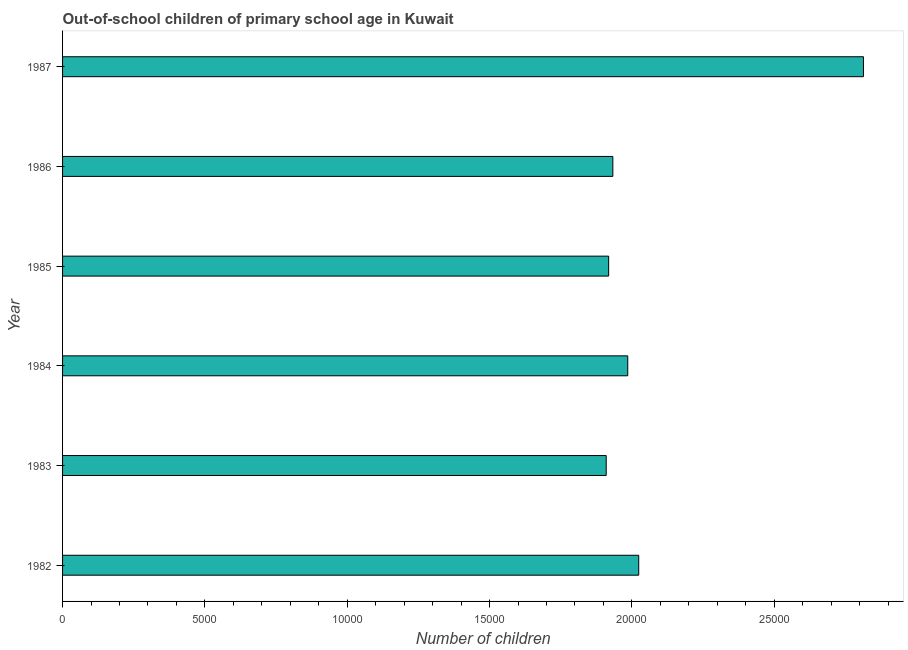Does the graph contain any zero values?
Give a very brief answer. No. What is the title of the graph?
Offer a terse response. Out-of-school children of primary school age in Kuwait. What is the label or title of the X-axis?
Your answer should be very brief. Number of children. What is the number of out-of-school children in 1982?
Make the answer very short. 2.02e+04. Across all years, what is the maximum number of out-of-school children?
Keep it short and to the point. 2.81e+04. Across all years, what is the minimum number of out-of-school children?
Ensure brevity in your answer.  1.91e+04. In which year was the number of out-of-school children minimum?
Your response must be concise. 1983. What is the sum of the number of out-of-school children?
Provide a short and direct response. 1.26e+05. What is the difference between the number of out-of-school children in 1982 and 1983?
Give a very brief answer. 1142. What is the average number of out-of-school children per year?
Make the answer very short. 2.10e+04. What is the median number of out-of-school children?
Your answer should be very brief. 1.96e+04. In how many years, is the number of out-of-school children greater than 8000 ?
Provide a succinct answer. 6. Do a majority of the years between 1984 and 1982 (inclusive) have number of out-of-school children greater than 15000 ?
Provide a succinct answer. Yes. What is the ratio of the number of out-of-school children in 1985 to that in 1986?
Provide a short and direct response. 0.99. What is the difference between the highest and the second highest number of out-of-school children?
Provide a succinct answer. 7895. Is the sum of the number of out-of-school children in 1984 and 1987 greater than the maximum number of out-of-school children across all years?
Ensure brevity in your answer.  Yes. What is the difference between the highest and the lowest number of out-of-school children?
Offer a terse response. 9037. Are all the bars in the graph horizontal?
Ensure brevity in your answer.  Yes. What is the difference between two consecutive major ticks on the X-axis?
Your answer should be compact. 5000. What is the Number of children of 1982?
Ensure brevity in your answer.  2.02e+04. What is the Number of children in 1983?
Your answer should be compact. 1.91e+04. What is the Number of children in 1984?
Your answer should be compact. 1.99e+04. What is the Number of children in 1985?
Keep it short and to the point. 1.92e+04. What is the Number of children in 1986?
Give a very brief answer. 1.93e+04. What is the Number of children of 1987?
Your response must be concise. 2.81e+04. What is the difference between the Number of children in 1982 and 1983?
Your answer should be very brief. 1142. What is the difference between the Number of children in 1982 and 1984?
Your answer should be compact. 385. What is the difference between the Number of children in 1982 and 1985?
Keep it short and to the point. 1056. What is the difference between the Number of children in 1982 and 1986?
Offer a terse response. 909. What is the difference between the Number of children in 1982 and 1987?
Ensure brevity in your answer.  -7895. What is the difference between the Number of children in 1983 and 1984?
Offer a very short reply. -757. What is the difference between the Number of children in 1983 and 1985?
Provide a short and direct response. -86. What is the difference between the Number of children in 1983 and 1986?
Provide a short and direct response. -233. What is the difference between the Number of children in 1983 and 1987?
Provide a succinct answer. -9037. What is the difference between the Number of children in 1984 and 1985?
Make the answer very short. 671. What is the difference between the Number of children in 1984 and 1986?
Provide a succinct answer. 524. What is the difference between the Number of children in 1984 and 1987?
Make the answer very short. -8280. What is the difference between the Number of children in 1985 and 1986?
Your response must be concise. -147. What is the difference between the Number of children in 1985 and 1987?
Keep it short and to the point. -8951. What is the difference between the Number of children in 1986 and 1987?
Give a very brief answer. -8804. What is the ratio of the Number of children in 1982 to that in 1983?
Offer a very short reply. 1.06. What is the ratio of the Number of children in 1982 to that in 1985?
Offer a terse response. 1.05. What is the ratio of the Number of children in 1982 to that in 1986?
Provide a short and direct response. 1.05. What is the ratio of the Number of children in 1982 to that in 1987?
Keep it short and to the point. 0.72. What is the ratio of the Number of children in 1983 to that in 1984?
Provide a short and direct response. 0.96. What is the ratio of the Number of children in 1983 to that in 1985?
Your answer should be compact. 1. What is the ratio of the Number of children in 1983 to that in 1986?
Your answer should be very brief. 0.99. What is the ratio of the Number of children in 1983 to that in 1987?
Your answer should be very brief. 0.68. What is the ratio of the Number of children in 1984 to that in 1985?
Provide a short and direct response. 1.03. What is the ratio of the Number of children in 1984 to that in 1986?
Offer a very short reply. 1.03. What is the ratio of the Number of children in 1984 to that in 1987?
Keep it short and to the point. 0.71. What is the ratio of the Number of children in 1985 to that in 1986?
Give a very brief answer. 0.99. What is the ratio of the Number of children in 1985 to that in 1987?
Keep it short and to the point. 0.68. What is the ratio of the Number of children in 1986 to that in 1987?
Ensure brevity in your answer.  0.69. 